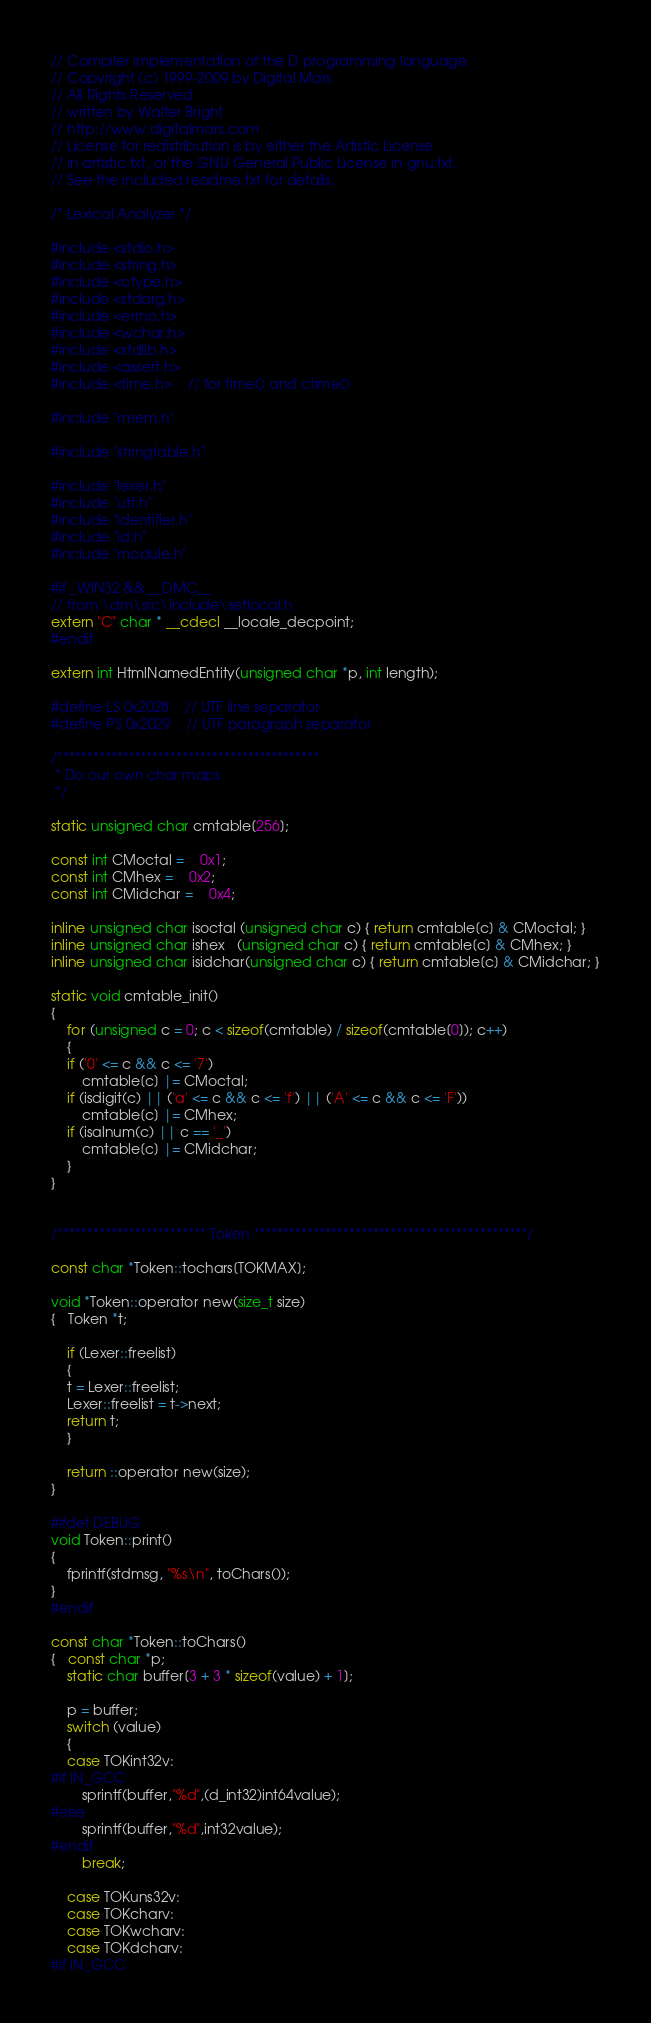<code> <loc_0><loc_0><loc_500><loc_500><_C_>
// Compiler implementation of the D programming language
// Copyright (c) 1999-2009 by Digital Mars
// All Rights Reserved
// written by Walter Bright
// http://www.digitalmars.com
// License for redistribution is by either the Artistic License
// in artistic.txt, or the GNU General Public License in gnu.txt.
// See the included readme.txt for details.

/* Lexical Analyzer */

#include <stdio.h>
#include <string.h>
#include <ctype.h>
#include <stdarg.h>
#include <errno.h>
#include <wchar.h>
#include <stdlib.h>
#include <assert.h>
#include <time.h>	// for time() and ctime()

#include "rmem.h"

#include "stringtable.h"

#include "lexer.h"
#include "utf.h"
#include "identifier.h"
#include "id.h"
#include "module.h"

#if _WIN32 && __DMC__
// from \dm\src\include\setlocal.h
extern "C" char * __cdecl __locale_decpoint;
#endif

extern int HtmlNamedEntity(unsigned char *p, int length);

#define LS 0x2028	// UTF line separator
#define PS 0x2029	// UTF paragraph separator

/********************************************
 * Do our own char maps
 */

static unsigned char cmtable[256];

const int CMoctal =	0x1;
const int CMhex =	0x2;
const int CMidchar =	0x4;

inline unsigned char isoctal (unsigned char c) { return cmtable[c] & CMoctal; }
inline unsigned char ishex   (unsigned char c) { return cmtable[c] & CMhex; }
inline unsigned char isidchar(unsigned char c) { return cmtable[c] & CMidchar; }

static void cmtable_init()
{
    for (unsigned c = 0; c < sizeof(cmtable) / sizeof(cmtable[0]); c++)
    {
	if ('0' <= c && c <= '7')
	    cmtable[c] |= CMoctal;
	if (isdigit(c) || ('a' <= c && c <= 'f') || ('A' <= c && c <= 'F'))
	    cmtable[c] |= CMhex;
	if (isalnum(c) || c == '_')
	    cmtable[c] |= CMidchar;
    }
}


/************************* Token **********************************************/

const char *Token::tochars[TOKMAX];

void *Token::operator new(size_t size)
{   Token *t;

    if (Lexer::freelist)
    {
	t = Lexer::freelist;
	Lexer::freelist = t->next;
	return t;
    }

    return ::operator new(size);
}

#ifdef DEBUG
void Token::print()
{
    fprintf(stdmsg, "%s\n", toChars());
}
#endif

const char *Token::toChars()
{   const char *p;
    static char buffer[3 + 3 * sizeof(value) + 1];

    p = buffer;
    switch (value)
    {
	case TOKint32v:
#if IN_GCC
	    sprintf(buffer,"%d",(d_int32)int64value);
#else
	    sprintf(buffer,"%d",int32value);
#endif
	    break;

	case TOKuns32v:
	case TOKcharv:
	case TOKwcharv:
	case TOKdcharv:
#if IN_GCC</code> 